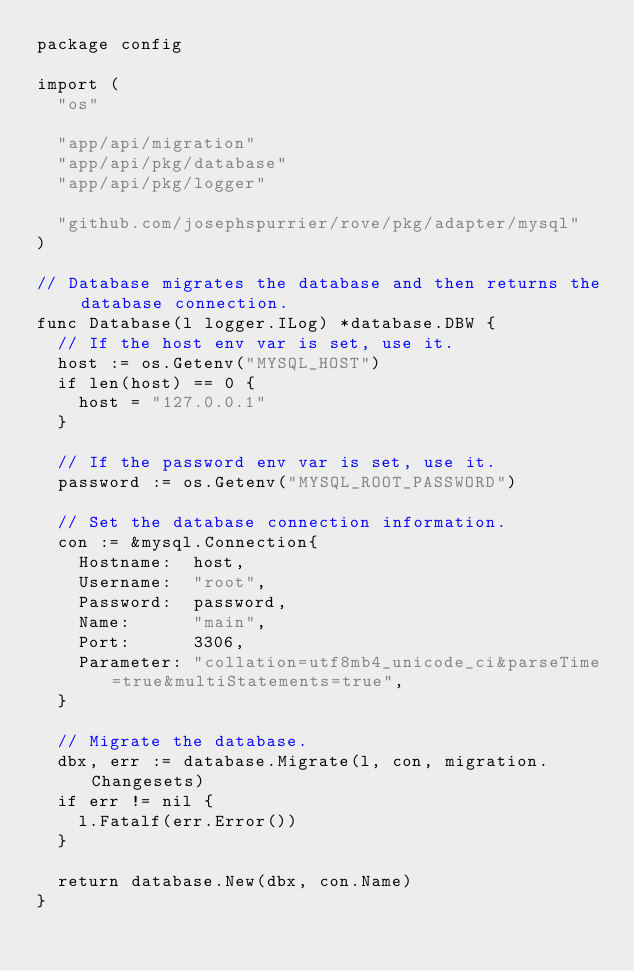Convert code to text. <code><loc_0><loc_0><loc_500><loc_500><_Go_>package config

import (
	"os"

	"app/api/migration"
	"app/api/pkg/database"
	"app/api/pkg/logger"

	"github.com/josephspurrier/rove/pkg/adapter/mysql"
)

// Database migrates the database and then returns the database connection.
func Database(l logger.ILog) *database.DBW {
	// If the host env var is set, use it.
	host := os.Getenv("MYSQL_HOST")
	if len(host) == 0 {
		host = "127.0.0.1"
	}

	// If the password env var is set, use it.
	password := os.Getenv("MYSQL_ROOT_PASSWORD")

	// Set the database connection information.
	con := &mysql.Connection{
		Hostname:  host,
		Username:  "root",
		Password:  password,
		Name:      "main",
		Port:      3306,
		Parameter: "collation=utf8mb4_unicode_ci&parseTime=true&multiStatements=true",
	}

	// Migrate the database.
	dbx, err := database.Migrate(l, con, migration.Changesets)
	if err != nil {
		l.Fatalf(err.Error())
	}

	return database.New(dbx, con.Name)
}
</code> 